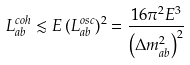<formula> <loc_0><loc_0><loc_500><loc_500>L _ { a b } ^ { c o h } \lesssim E \, ( L _ { a b } ^ { o s c } ) ^ { 2 } = \frac { 1 6 \pi ^ { 2 } E ^ { 3 } } { \left ( \Delta { m } _ { a b } ^ { 2 } \right ) ^ { 2 } }</formula> 